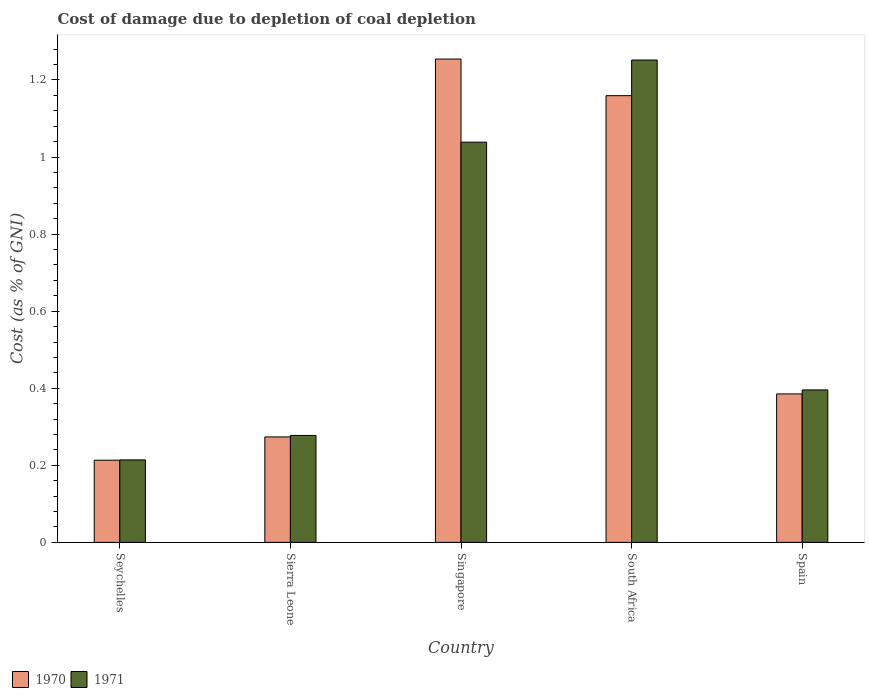How many different coloured bars are there?
Your answer should be compact. 2. Are the number of bars per tick equal to the number of legend labels?
Your answer should be very brief. Yes. Are the number of bars on each tick of the X-axis equal?
Give a very brief answer. Yes. How many bars are there on the 5th tick from the left?
Offer a very short reply. 2. How many bars are there on the 3rd tick from the right?
Make the answer very short. 2. What is the label of the 2nd group of bars from the left?
Ensure brevity in your answer.  Sierra Leone. What is the cost of damage caused due to coal depletion in 1970 in Singapore?
Offer a terse response. 1.25. Across all countries, what is the maximum cost of damage caused due to coal depletion in 1970?
Offer a terse response. 1.25. Across all countries, what is the minimum cost of damage caused due to coal depletion in 1971?
Make the answer very short. 0.21. In which country was the cost of damage caused due to coal depletion in 1970 maximum?
Keep it short and to the point. Singapore. In which country was the cost of damage caused due to coal depletion in 1970 minimum?
Give a very brief answer. Seychelles. What is the total cost of damage caused due to coal depletion in 1971 in the graph?
Your answer should be very brief. 3.18. What is the difference between the cost of damage caused due to coal depletion in 1971 in Singapore and that in South Africa?
Ensure brevity in your answer.  -0.21. What is the difference between the cost of damage caused due to coal depletion in 1970 in Sierra Leone and the cost of damage caused due to coal depletion in 1971 in South Africa?
Keep it short and to the point. -0.98. What is the average cost of damage caused due to coal depletion in 1971 per country?
Your response must be concise. 0.64. What is the difference between the cost of damage caused due to coal depletion of/in 1970 and cost of damage caused due to coal depletion of/in 1971 in Seychelles?
Keep it short and to the point. -0. In how many countries, is the cost of damage caused due to coal depletion in 1970 greater than 0.68 %?
Keep it short and to the point. 2. What is the ratio of the cost of damage caused due to coal depletion in 1970 in Sierra Leone to that in Spain?
Make the answer very short. 0.71. Is the cost of damage caused due to coal depletion in 1970 in Sierra Leone less than that in Spain?
Your response must be concise. Yes. What is the difference between the highest and the second highest cost of damage caused due to coal depletion in 1970?
Make the answer very short. -0.87. What is the difference between the highest and the lowest cost of damage caused due to coal depletion in 1971?
Give a very brief answer. 1.04. In how many countries, is the cost of damage caused due to coal depletion in 1970 greater than the average cost of damage caused due to coal depletion in 1970 taken over all countries?
Ensure brevity in your answer.  2. Is the sum of the cost of damage caused due to coal depletion in 1970 in Sierra Leone and Spain greater than the maximum cost of damage caused due to coal depletion in 1971 across all countries?
Your answer should be very brief. No. What does the 2nd bar from the right in Singapore represents?
Your response must be concise. 1970. How many bars are there?
Ensure brevity in your answer.  10. How many countries are there in the graph?
Your response must be concise. 5. How many legend labels are there?
Make the answer very short. 2. How are the legend labels stacked?
Offer a terse response. Horizontal. What is the title of the graph?
Ensure brevity in your answer.  Cost of damage due to depletion of coal depletion. Does "1964" appear as one of the legend labels in the graph?
Make the answer very short. No. What is the label or title of the X-axis?
Provide a short and direct response. Country. What is the label or title of the Y-axis?
Keep it short and to the point. Cost (as % of GNI). What is the Cost (as % of GNI) in 1970 in Seychelles?
Give a very brief answer. 0.21. What is the Cost (as % of GNI) of 1971 in Seychelles?
Offer a terse response. 0.21. What is the Cost (as % of GNI) of 1970 in Sierra Leone?
Keep it short and to the point. 0.27. What is the Cost (as % of GNI) of 1971 in Sierra Leone?
Ensure brevity in your answer.  0.28. What is the Cost (as % of GNI) in 1970 in Singapore?
Your answer should be very brief. 1.25. What is the Cost (as % of GNI) of 1971 in Singapore?
Provide a succinct answer. 1.04. What is the Cost (as % of GNI) of 1970 in South Africa?
Make the answer very short. 1.16. What is the Cost (as % of GNI) of 1971 in South Africa?
Offer a terse response. 1.25. What is the Cost (as % of GNI) in 1970 in Spain?
Your response must be concise. 0.39. What is the Cost (as % of GNI) of 1971 in Spain?
Your answer should be compact. 0.4. Across all countries, what is the maximum Cost (as % of GNI) in 1970?
Ensure brevity in your answer.  1.25. Across all countries, what is the maximum Cost (as % of GNI) in 1971?
Provide a succinct answer. 1.25. Across all countries, what is the minimum Cost (as % of GNI) in 1970?
Give a very brief answer. 0.21. Across all countries, what is the minimum Cost (as % of GNI) of 1971?
Keep it short and to the point. 0.21. What is the total Cost (as % of GNI) in 1970 in the graph?
Ensure brevity in your answer.  3.29. What is the total Cost (as % of GNI) in 1971 in the graph?
Make the answer very short. 3.18. What is the difference between the Cost (as % of GNI) of 1970 in Seychelles and that in Sierra Leone?
Provide a succinct answer. -0.06. What is the difference between the Cost (as % of GNI) in 1971 in Seychelles and that in Sierra Leone?
Your answer should be compact. -0.06. What is the difference between the Cost (as % of GNI) of 1970 in Seychelles and that in Singapore?
Offer a very short reply. -1.04. What is the difference between the Cost (as % of GNI) of 1971 in Seychelles and that in Singapore?
Offer a very short reply. -0.82. What is the difference between the Cost (as % of GNI) of 1970 in Seychelles and that in South Africa?
Offer a very short reply. -0.95. What is the difference between the Cost (as % of GNI) of 1971 in Seychelles and that in South Africa?
Provide a succinct answer. -1.04. What is the difference between the Cost (as % of GNI) of 1970 in Seychelles and that in Spain?
Your answer should be compact. -0.17. What is the difference between the Cost (as % of GNI) of 1971 in Seychelles and that in Spain?
Offer a very short reply. -0.18. What is the difference between the Cost (as % of GNI) in 1970 in Sierra Leone and that in Singapore?
Ensure brevity in your answer.  -0.98. What is the difference between the Cost (as % of GNI) of 1971 in Sierra Leone and that in Singapore?
Your answer should be compact. -0.76. What is the difference between the Cost (as % of GNI) in 1970 in Sierra Leone and that in South Africa?
Make the answer very short. -0.89. What is the difference between the Cost (as % of GNI) in 1971 in Sierra Leone and that in South Africa?
Offer a terse response. -0.97. What is the difference between the Cost (as % of GNI) in 1970 in Sierra Leone and that in Spain?
Give a very brief answer. -0.11. What is the difference between the Cost (as % of GNI) of 1971 in Sierra Leone and that in Spain?
Your answer should be very brief. -0.12. What is the difference between the Cost (as % of GNI) of 1970 in Singapore and that in South Africa?
Ensure brevity in your answer.  0.1. What is the difference between the Cost (as % of GNI) in 1971 in Singapore and that in South Africa?
Your answer should be very brief. -0.21. What is the difference between the Cost (as % of GNI) of 1970 in Singapore and that in Spain?
Your answer should be compact. 0.87. What is the difference between the Cost (as % of GNI) of 1971 in Singapore and that in Spain?
Provide a short and direct response. 0.64. What is the difference between the Cost (as % of GNI) of 1970 in South Africa and that in Spain?
Ensure brevity in your answer.  0.77. What is the difference between the Cost (as % of GNI) in 1971 in South Africa and that in Spain?
Offer a very short reply. 0.86. What is the difference between the Cost (as % of GNI) in 1970 in Seychelles and the Cost (as % of GNI) in 1971 in Sierra Leone?
Offer a very short reply. -0.06. What is the difference between the Cost (as % of GNI) of 1970 in Seychelles and the Cost (as % of GNI) of 1971 in Singapore?
Give a very brief answer. -0.83. What is the difference between the Cost (as % of GNI) in 1970 in Seychelles and the Cost (as % of GNI) in 1971 in South Africa?
Keep it short and to the point. -1.04. What is the difference between the Cost (as % of GNI) in 1970 in Seychelles and the Cost (as % of GNI) in 1971 in Spain?
Your answer should be very brief. -0.18. What is the difference between the Cost (as % of GNI) in 1970 in Sierra Leone and the Cost (as % of GNI) in 1971 in Singapore?
Your response must be concise. -0.77. What is the difference between the Cost (as % of GNI) of 1970 in Sierra Leone and the Cost (as % of GNI) of 1971 in South Africa?
Make the answer very short. -0.98. What is the difference between the Cost (as % of GNI) of 1970 in Sierra Leone and the Cost (as % of GNI) of 1971 in Spain?
Give a very brief answer. -0.12. What is the difference between the Cost (as % of GNI) in 1970 in Singapore and the Cost (as % of GNI) in 1971 in South Africa?
Your answer should be very brief. 0. What is the difference between the Cost (as % of GNI) in 1970 in Singapore and the Cost (as % of GNI) in 1971 in Spain?
Provide a short and direct response. 0.86. What is the difference between the Cost (as % of GNI) of 1970 in South Africa and the Cost (as % of GNI) of 1971 in Spain?
Keep it short and to the point. 0.76. What is the average Cost (as % of GNI) in 1970 per country?
Give a very brief answer. 0.66. What is the average Cost (as % of GNI) of 1971 per country?
Make the answer very short. 0.64. What is the difference between the Cost (as % of GNI) of 1970 and Cost (as % of GNI) of 1971 in Seychelles?
Keep it short and to the point. -0. What is the difference between the Cost (as % of GNI) of 1970 and Cost (as % of GNI) of 1971 in Sierra Leone?
Make the answer very short. -0. What is the difference between the Cost (as % of GNI) in 1970 and Cost (as % of GNI) in 1971 in Singapore?
Give a very brief answer. 0.22. What is the difference between the Cost (as % of GNI) in 1970 and Cost (as % of GNI) in 1971 in South Africa?
Offer a terse response. -0.09. What is the difference between the Cost (as % of GNI) in 1970 and Cost (as % of GNI) in 1971 in Spain?
Make the answer very short. -0.01. What is the ratio of the Cost (as % of GNI) in 1970 in Seychelles to that in Sierra Leone?
Ensure brevity in your answer.  0.78. What is the ratio of the Cost (as % of GNI) in 1971 in Seychelles to that in Sierra Leone?
Ensure brevity in your answer.  0.77. What is the ratio of the Cost (as % of GNI) of 1970 in Seychelles to that in Singapore?
Your response must be concise. 0.17. What is the ratio of the Cost (as % of GNI) of 1971 in Seychelles to that in Singapore?
Your answer should be compact. 0.21. What is the ratio of the Cost (as % of GNI) in 1970 in Seychelles to that in South Africa?
Ensure brevity in your answer.  0.18. What is the ratio of the Cost (as % of GNI) of 1971 in Seychelles to that in South Africa?
Provide a succinct answer. 0.17. What is the ratio of the Cost (as % of GNI) in 1970 in Seychelles to that in Spain?
Offer a very short reply. 0.55. What is the ratio of the Cost (as % of GNI) of 1971 in Seychelles to that in Spain?
Make the answer very short. 0.54. What is the ratio of the Cost (as % of GNI) in 1970 in Sierra Leone to that in Singapore?
Offer a terse response. 0.22. What is the ratio of the Cost (as % of GNI) of 1971 in Sierra Leone to that in Singapore?
Give a very brief answer. 0.27. What is the ratio of the Cost (as % of GNI) in 1970 in Sierra Leone to that in South Africa?
Your answer should be very brief. 0.24. What is the ratio of the Cost (as % of GNI) of 1971 in Sierra Leone to that in South Africa?
Give a very brief answer. 0.22. What is the ratio of the Cost (as % of GNI) in 1970 in Sierra Leone to that in Spain?
Offer a very short reply. 0.71. What is the ratio of the Cost (as % of GNI) in 1971 in Sierra Leone to that in Spain?
Provide a short and direct response. 0.7. What is the ratio of the Cost (as % of GNI) of 1970 in Singapore to that in South Africa?
Ensure brevity in your answer.  1.08. What is the ratio of the Cost (as % of GNI) of 1971 in Singapore to that in South Africa?
Make the answer very short. 0.83. What is the ratio of the Cost (as % of GNI) of 1970 in Singapore to that in Spain?
Ensure brevity in your answer.  3.26. What is the ratio of the Cost (as % of GNI) of 1971 in Singapore to that in Spain?
Your answer should be compact. 2.63. What is the ratio of the Cost (as % of GNI) of 1970 in South Africa to that in Spain?
Your answer should be compact. 3.01. What is the ratio of the Cost (as % of GNI) of 1971 in South Africa to that in Spain?
Provide a succinct answer. 3.16. What is the difference between the highest and the second highest Cost (as % of GNI) in 1970?
Offer a terse response. 0.1. What is the difference between the highest and the second highest Cost (as % of GNI) in 1971?
Make the answer very short. 0.21. What is the difference between the highest and the lowest Cost (as % of GNI) of 1970?
Give a very brief answer. 1.04. What is the difference between the highest and the lowest Cost (as % of GNI) in 1971?
Give a very brief answer. 1.04. 